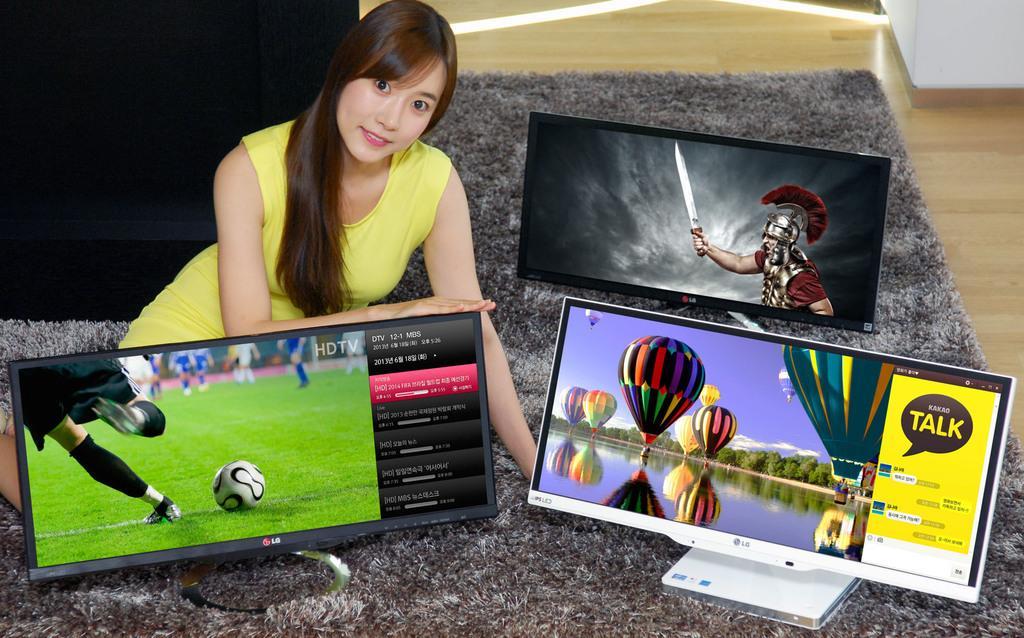Describe this image in one or two sentences. In the picture I can see a woman wearing a yellow color dress is lying on the carpet which is placed on the wooden floor. Here we can see three monitors in which something is displayed. 